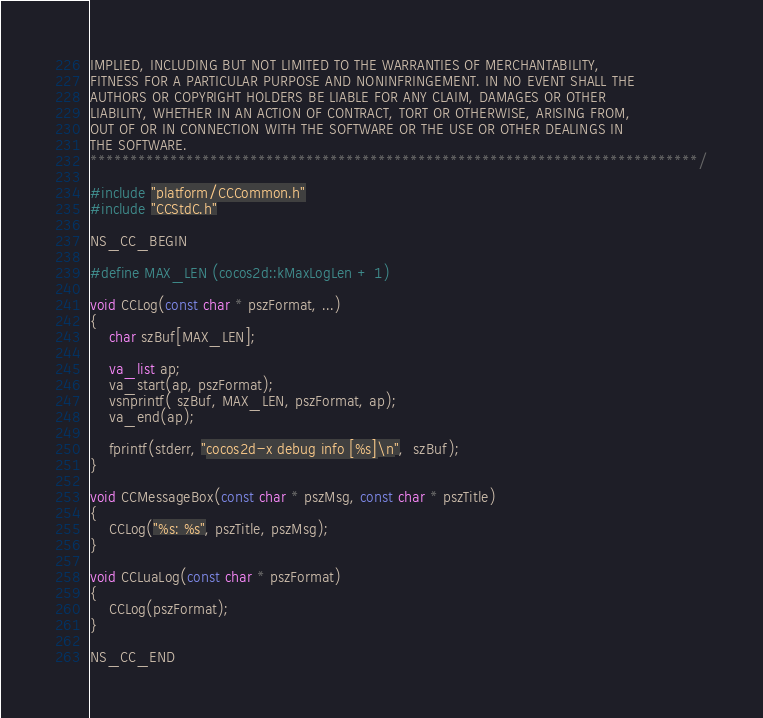<code> <loc_0><loc_0><loc_500><loc_500><_C++_>IMPLIED, INCLUDING BUT NOT LIMITED TO THE WARRANTIES OF MERCHANTABILITY,
FITNESS FOR A PARTICULAR PURPOSE AND NONINFRINGEMENT. IN NO EVENT SHALL THE
AUTHORS OR COPYRIGHT HOLDERS BE LIABLE FOR ANY CLAIM, DAMAGES OR OTHER
LIABILITY, WHETHER IN AN ACTION OF CONTRACT, TORT OR OTHERWISE, ARISING FROM,
OUT OF OR IN CONNECTION WITH THE SOFTWARE OR THE USE OR OTHER DEALINGS IN
THE SOFTWARE.
****************************************************************************/

#include "platform/CCCommon.h"
#include "CCStdC.h"

NS_CC_BEGIN

#define MAX_LEN (cocos2d::kMaxLogLen + 1)

void CCLog(const char * pszFormat, ...)
{
    char szBuf[MAX_LEN];

    va_list ap;
    va_start(ap, pszFormat);
    vsnprintf( szBuf, MAX_LEN, pszFormat, ap);
    va_end(ap);

    fprintf(stderr, "cocos2d-x debug info [%s]\n",  szBuf);
}

void CCMessageBox(const char * pszMsg, const char * pszTitle)
{
    CCLog("%s: %s", pszTitle, pszMsg);
}

void CCLuaLog(const char * pszFormat)
{
    CCLog(pszFormat);
}

NS_CC_END
</code> 